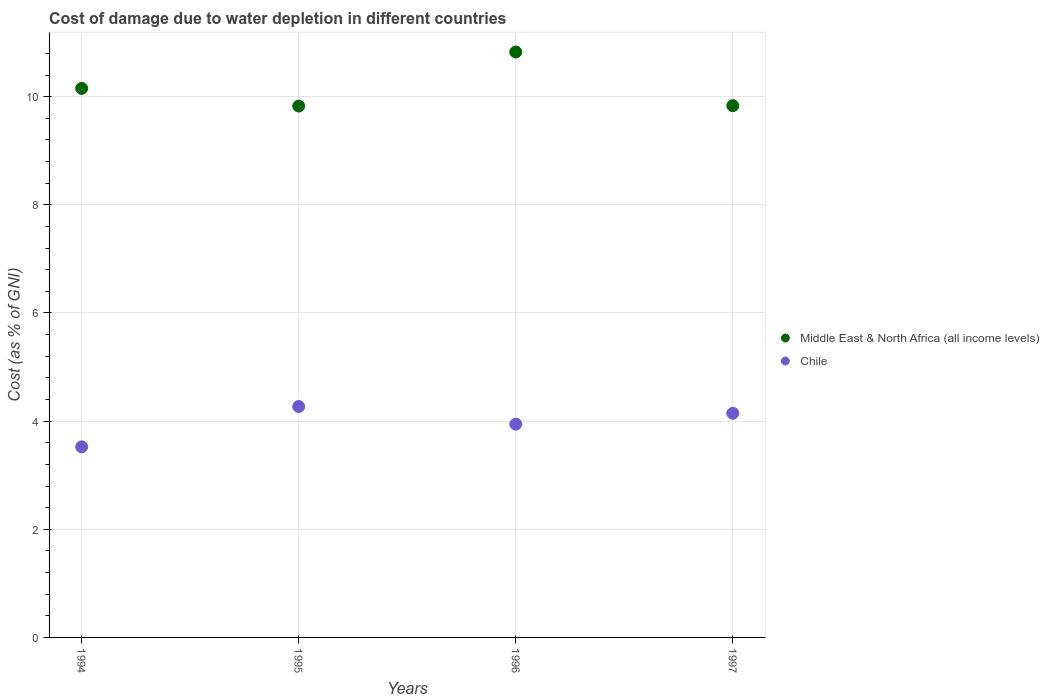Is the number of dotlines equal to the number of legend labels?
Offer a terse response. Yes. What is the cost of damage caused due to water depletion in Chile in 1996?
Give a very brief answer. 3.94. Across all years, what is the maximum cost of damage caused due to water depletion in Middle East & North Africa (all income levels)?
Give a very brief answer. 10.83. Across all years, what is the minimum cost of damage caused due to water depletion in Middle East & North Africa (all income levels)?
Keep it short and to the point. 9.83. In which year was the cost of damage caused due to water depletion in Middle East & North Africa (all income levels) maximum?
Make the answer very short. 1996. What is the total cost of damage caused due to water depletion in Chile in the graph?
Your response must be concise. 15.88. What is the difference between the cost of damage caused due to water depletion in Chile in 1995 and that in 1997?
Your answer should be very brief. 0.13. What is the difference between the cost of damage caused due to water depletion in Middle East & North Africa (all income levels) in 1994 and the cost of damage caused due to water depletion in Chile in 1996?
Provide a succinct answer. 6.21. What is the average cost of damage caused due to water depletion in Middle East & North Africa (all income levels) per year?
Ensure brevity in your answer.  10.16. In the year 1997, what is the difference between the cost of damage caused due to water depletion in Chile and cost of damage caused due to water depletion in Middle East & North Africa (all income levels)?
Your answer should be compact. -5.69. What is the ratio of the cost of damage caused due to water depletion in Chile in 1994 to that in 1997?
Your response must be concise. 0.85. Is the difference between the cost of damage caused due to water depletion in Chile in 1995 and 1996 greater than the difference between the cost of damage caused due to water depletion in Middle East & North Africa (all income levels) in 1995 and 1996?
Provide a succinct answer. Yes. What is the difference between the highest and the second highest cost of damage caused due to water depletion in Chile?
Offer a very short reply. 0.13. What is the difference between the highest and the lowest cost of damage caused due to water depletion in Middle East & North Africa (all income levels)?
Offer a very short reply. 1. Is the cost of damage caused due to water depletion in Chile strictly greater than the cost of damage caused due to water depletion in Middle East & North Africa (all income levels) over the years?
Keep it short and to the point. No. Is the cost of damage caused due to water depletion in Middle East & North Africa (all income levels) strictly less than the cost of damage caused due to water depletion in Chile over the years?
Your response must be concise. No. How many dotlines are there?
Offer a very short reply. 2. How many years are there in the graph?
Give a very brief answer. 4. Does the graph contain any zero values?
Make the answer very short. No. Does the graph contain grids?
Offer a terse response. Yes. How many legend labels are there?
Your answer should be very brief. 2. How are the legend labels stacked?
Your answer should be very brief. Vertical. What is the title of the graph?
Make the answer very short. Cost of damage due to water depletion in different countries. Does "OECD members" appear as one of the legend labels in the graph?
Provide a succinct answer. No. What is the label or title of the Y-axis?
Your response must be concise. Cost (as % of GNI). What is the Cost (as % of GNI) of Middle East & North Africa (all income levels) in 1994?
Offer a terse response. 10.15. What is the Cost (as % of GNI) in Chile in 1994?
Your answer should be very brief. 3.52. What is the Cost (as % of GNI) in Middle East & North Africa (all income levels) in 1995?
Your answer should be compact. 9.83. What is the Cost (as % of GNI) in Chile in 1995?
Your response must be concise. 4.27. What is the Cost (as % of GNI) in Middle East & North Africa (all income levels) in 1996?
Your answer should be very brief. 10.83. What is the Cost (as % of GNI) in Chile in 1996?
Provide a short and direct response. 3.94. What is the Cost (as % of GNI) of Middle East & North Africa (all income levels) in 1997?
Offer a very short reply. 9.83. What is the Cost (as % of GNI) in Chile in 1997?
Keep it short and to the point. 4.15. Across all years, what is the maximum Cost (as % of GNI) of Middle East & North Africa (all income levels)?
Make the answer very short. 10.83. Across all years, what is the maximum Cost (as % of GNI) in Chile?
Keep it short and to the point. 4.27. Across all years, what is the minimum Cost (as % of GNI) in Middle East & North Africa (all income levels)?
Your answer should be very brief. 9.83. Across all years, what is the minimum Cost (as % of GNI) of Chile?
Provide a succinct answer. 3.52. What is the total Cost (as % of GNI) in Middle East & North Africa (all income levels) in the graph?
Provide a succinct answer. 40.64. What is the total Cost (as % of GNI) in Chile in the graph?
Your answer should be very brief. 15.88. What is the difference between the Cost (as % of GNI) of Middle East & North Africa (all income levels) in 1994 and that in 1995?
Your answer should be compact. 0.33. What is the difference between the Cost (as % of GNI) of Chile in 1994 and that in 1995?
Your response must be concise. -0.75. What is the difference between the Cost (as % of GNI) in Middle East & North Africa (all income levels) in 1994 and that in 1996?
Offer a terse response. -0.67. What is the difference between the Cost (as % of GNI) of Chile in 1994 and that in 1996?
Your response must be concise. -0.42. What is the difference between the Cost (as % of GNI) of Middle East & North Africa (all income levels) in 1994 and that in 1997?
Provide a succinct answer. 0.32. What is the difference between the Cost (as % of GNI) in Chile in 1994 and that in 1997?
Your answer should be very brief. -0.62. What is the difference between the Cost (as % of GNI) in Middle East & North Africa (all income levels) in 1995 and that in 1996?
Offer a terse response. -1. What is the difference between the Cost (as % of GNI) in Chile in 1995 and that in 1996?
Give a very brief answer. 0.33. What is the difference between the Cost (as % of GNI) in Middle East & North Africa (all income levels) in 1995 and that in 1997?
Keep it short and to the point. -0.01. What is the difference between the Cost (as % of GNI) in Chile in 1995 and that in 1997?
Provide a short and direct response. 0.13. What is the difference between the Cost (as % of GNI) in Middle East & North Africa (all income levels) in 1996 and that in 1997?
Ensure brevity in your answer.  0.99. What is the difference between the Cost (as % of GNI) in Chile in 1996 and that in 1997?
Your answer should be compact. -0.2. What is the difference between the Cost (as % of GNI) of Middle East & North Africa (all income levels) in 1994 and the Cost (as % of GNI) of Chile in 1995?
Provide a short and direct response. 5.88. What is the difference between the Cost (as % of GNI) in Middle East & North Africa (all income levels) in 1994 and the Cost (as % of GNI) in Chile in 1996?
Offer a terse response. 6.21. What is the difference between the Cost (as % of GNI) of Middle East & North Africa (all income levels) in 1994 and the Cost (as % of GNI) of Chile in 1997?
Keep it short and to the point. 6.01. What is the difference between the Cost (as % of GNI) of Middle East & North Africa (all income levels) in 1995 and the Cost (as % of GNI) of Chile in 1996?
Your response must be concise. 5.88. What is the difference between the Cost (as % of GNI) of Middle East & North Africa (all income levels) in 1995 and the Cost (as % of GNI) of Chile in 1997?
Keep it short and to the point. 5.68. What is the difference between the Cost (as % of GNI) in Middle East & North Africa (all income levels) in 1996 and the Cost (as % of GNI) in Chile in 1997?
Keep it short and to the point. 6.68. What is the average Cost (as % of GNI) of Middle East & North Africa (all income levels) per year?
Offer a very short reply. 10.16. What is the average Cost (as % of GNI) of Chile per year?
Make the answer very short. 3.97. In the year 1994, what is the difference between the Cost (as % of GNI) of Middle East & North Africa (all income levels) and Cost (as % of GNI) of Chile?
Keep it short and to the point. 6.63. In the year 1995, what is the difference between the Cost (as % of GNI) of Middle East & North Africa (all income levels) and Cost (as % of GNI) of Chile?
Your response must be concise. 5.56. In the year 1996, what is the difference between the Cost (as % of GNI) in Middle East & North Africa (all income levels) and Cost (as % of GNI) in Chile?
Offer a very short reply. 6.88. In the year 1997, what is the difference between the Cost (as % of GNI) of Middle East & North Africa (all income levels) and Cost (as % of GNI) of Chile?
Keep it short and to the point. 5.69. What is the ratio of the Cost (as % of GNI) in Middle East & North Africa (all income levels) in 1994 to that in 1995?
Your answer should be very brief. 1.03. What is the ratio of the Cost (as % of GNI) in Chile in 1994 to that in 1995?
Provide a succinct answer. 0.83. What is the ratio of the Cost (as % of GNI) in Middle East & North Africa (all income levels) in 1994 to that in 1996?
Provide a succinct answer. 0.94. What is the ratio of the Cost (as % of GNI) in Chile in 1994 to that in 1996?
Offer a terse response. 0.89. What is the ratio of the Cost (as % of GNI) in Middle East & North Africa (all income levels) in 1994 to that in 1997?
Provide a succinct answer. 1.03. What is the ratio of the Cost (as % of GNI) in Chile in 1994 to that in 1997?
Give a very brief answer. 0.85. What is the ratio of the Cost (as % of GNI) of Middle East & North Africa (all income levels) in 1995 to that in 1996?
Give a very brief answer. 0.91. What is the ratio of the Cost (as % of GNI) in Chile in 1995 to that in 1996?
Your response must be concise. 1.08. What is the ratio of the Cost (as % of GNI) in Middle East & North Africa (all income levels) in 1995 to that in 1997?
Offer a terse response. 1. What is the ratio of the Cost (as % of GNI) in Chile in 1995 to that in 1997?
Offer a terse response. 1.03. What is the ratio of the Cost (as % of GNI) of Middle East & North Africa (all income levels) in 1996 to that in 1997?
Make the answer very short. 1.1. What is the ratio of the Cost (as % of GNI) of Chile in 1996 to that in 1997?
Ensure brevity in your answer.  0.95. What is the difference between the highest and the second highest Cost (as % of GNI) of Middle East & North Africa (all income levels)?
Provide a succinct answer. 0.67. What is the difference between the highest and the second highest Cost (as % of GNI) of Chile?
Make the answer very short. 0.13. What is the difference between the highest and the lowest Cost (as % of GNI) of Middle East & North Africa (all income levels)?
Offer a very short reply. 1. What is the difference between the highest and the lowest Cost (as % of GNI) of Chile?
Make the answer very short. 0.75. 